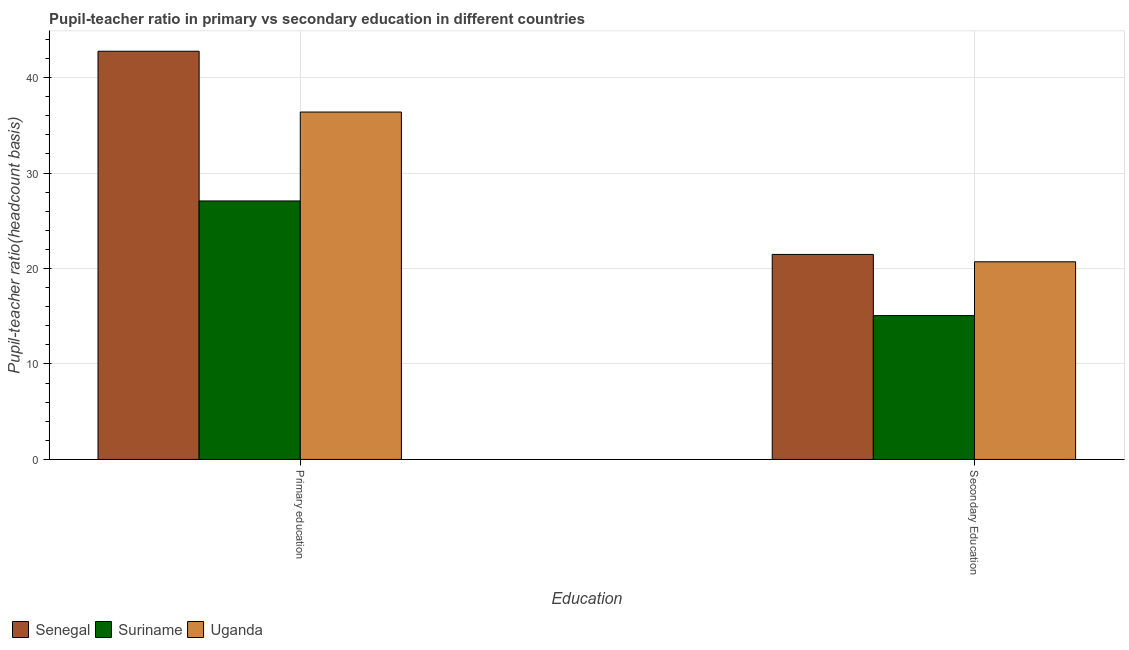Are the number of bars per tick equal to the number of legend labels?
Make the answer very short. Yes. How many bars are there on the 2nd tick from the left?
Keep it short and to the point. 3. How many bars are there on the 2nd tick from the right?
Provide a succinct answer. 3. What is the pupil-teacher ratio in primary education in Uganda?
Give a very brief answer. 36.39. Across all countries, what is the maximum pupil teacher ratio on secondary education?
Ensure brevity in your answer.  21.48. Across all countries, what is the minimum pupil teacher ratio on secondary education?
Your answer should be very brief. 15.07. In which country was the pupil teacher ratio on secondary education maximum?
Provide a short and direct response. Senegal. In which country was the pupil-teacher ratio in primary education minimum?
Provide a succinct answer. Suriname. What is the total pupil-teacher ratio in primary education in the graph?
Your answer should be compact. 106.23. What is the difference between the pupil-teacher ratio in primary education in Suriname and that in Senegal?
Offer a terse response. -15.68. What is the difference between the pupil-teacher ratio in primary education in Senegal and the pupil teacher ratio on secondary education in Suriname?
Make the answer very short. 27.7. What is the average pupil teacher ratio on secondary education per country?
Offer a very short reply. 19.08. What is the difference between the pupil teacher ratio on secondary education and pupil-teacher ratio in primary education in Uganda?
Provide a succinct answer. -15.69. In how many countries, is the pupil-teacher ratio in primary education greater than 32 ?
Provide a short and direct response. 2. What is the ratio of the pupil teacher ratio on secondary education in Suriname to that in Senegal?
Your answer should be very brief. 0.7. Is the pupil teacher ratio on secondary education in Uganda less than that in Senegal?
Ensure brevity in your answer.  Yes. What does the 3rd bar from the left in Primary education represents?
Give a very brief answer. Uganda. What does the 3rd bar from the right in Primary education represents?
Offer a terse response. Senegal. How many countries are there in the graph?
Offer a terse response. 3. Does the graph contain any zero values?
Offer a very short reply. No. Where does the legend appear in the graph?
Make the answer very short. Bottom left. How many legend labels are there?
Provide a short and direct response. 3. What is the title of the graph?
Your answer should be compact. Pupil-teacher ratio in primary vs secondary education in different countries. Does "Hungary" appear as one of the legend labels in the graph?
Offer a very short reply. No. What is the label or title of the X-axis?
Your response must be concise. Education. What is the label or title of the Y-axis?
Provide a short and direct response. Pupil-teacher ratio(headcount basis). What is the Pupil-teacher ratio(headcount basis) of Senegal in Primary education?
Your response must be concise. 42.76. What is the Pupil-teacher ratio(headcount basis) in Suriname in Primary education?
Offer a very short reply. 27.08. What is the Pupil-teacher ratio(headcount basis) of Uganda in Primary education?
Provide a short and direct response. 36.39. What is the Pupil-teacher ratio(headcount basis) in Senegal in Secondary Education?
Your answer should be very brief. 21.48. What is the Pupil-teacher ratio(headcount basis) of Suriname in Secondary Education?
Make the answer very short. 15.07. What is the Pupil-teacher ratio(headcount basis) in Uganda in Secondary Education?
Make the answer very short. 20.7. Across all Education, what is the maximum Pupil-teacher ratio(headcount basis) in Senegal?
Offer a terse response. 42.76. Across all Education, what is the maximum Pupil-teacher ratio(headcount basis) of Suriname?
Offer a terse response. 27.08. Across all Education, what is the maximum Pupil-teacher ratio(headcount basis) of Uganda?
Give a very brief answer. 36.39. Across all Education, what is the minimum Pupil-teacher ratio(headcount basis) in Senegal?
Give a very brief answer. 21.48. Across all Education, what is the minimum Pupil-teacher ratio(headcount basis) of Suriname?
Ensure brevity in your answer.  15.07. Across all Education, what is the minimum Pupil-teacher ratio(headcount basis) in Uganda?
Offer a terse response. 20.7. What is the total Pupil-teacher ratio(headcount basis) of Senegal in the graph?
Provide a short and direct response. 64.24. What is the total Pupil-teacher ratio(headcount basis) of Suriname in the graph?
Offer a terse response. 42.14. What is the total Pupil-teacher ratio(headcount basis) in Uganda in the graph?
Your answer should be compact. 57.1. What is the difference between the Pupil-teacher ratio(headcount basis) of Senegal in Primary education and that in Secondary Education?
Your response must be concise. 21.28. What is the difference between the Pupil-teacher ratio(headcount basis) in Suriname in Primary education and that in Secondary Education?
Your answer should be compact. 12.01. What is the difference between the Pupil-teacher ratio(headcount basis) in Uganda in Primary education and that in Secondary Education?
Offer a terse response. 15.69. What is the difference between the Pupil-teacher ratio(headcount basis) in Senegal in Primary education and the Pupil-teacher ratio(headcount basis) in Suriname in Secondary Education?
Provide a succinct answer. 27.7. What is the difference between the Pupil-teacher ratio(headcount basis) of Senegal in Primary education and the Pupil-teacher ratio(headcount basis) of Uganda in Secondary Education?
Offer a very short reply. 22.06. What is the difference between the Pupil-teacher ratio(headcount basis) in Suriname in Primary education and the Pupil-teacher ratio(headcount basis) in Uganda in Secondary Education?
Provide a succinct answer. 6.37. What is the average Pupil-teacher ratio(headcount basis) of Senegal per Education?
Your answer should be compact. 32.12. What is the average Pupil-teacher ratio(headcount basis) of Suriname per Education?
Provide a short and direct response. 21.07. What is the average Pupil-teacher ratio(headcount basis) in Uganda per Education?
Keep it short and to the point. 28.55. What is the difference between the Pupil-teacher ratio(headcount basis) of Senegal and Pupil-teacher ratio(headcount basis) of Suriname in Primary education?
Provide a short and direct response. 15.68. What is the difference between the Pupil-teacher ratio(headcount basis) of Senegal and Pupil-teacher ratio(headcount basis) of Uganda in Primary education?
Ensure brevity in your answer.  6.37. What is the difference between the Pupil-teacher ratio(headcount basis) in Suriname and Pupil-teacher ratio(headcount basis) in Uganda in Primary education?
Your response must be concise. -9.31. What is the difference between the Pupil-teacher ratio(headcount basis) of Senegal and Pupil-teacher ratio(headcount basis) of Suriname in Secondary Education?
Provide a succinct answer. 6.41. What is the difference between the Pupil-teacher ratio(headcount basis) in Senegal and Pupil-teacher ratio(headcount basis) in Uganda in Secondary Education?
Provide a succinct answer. 0.77. What is the difference between the Pupil-teacher ratio(headcount basis) of Suriname and Pupil-teacher ratio(headcount basis) of Uganda in Secondary Education?
Provide a short and direct response. -5.64. What is the ratio of the Pupil-teacher ratio(headcount basis) in Senegal in Primary education to that in Secondary Education?
Make the answer very short. 1.99. What is the ratio of the Pupil-teacher ratio(headcount basis) in Suriname in Primary education to that in Secondary Education?
Provide a succinct answer. 1.8. What is the ratio of the Pupil-teacher ratio(headcount basis) of Uganda in Primary education to that in Secondary Education?
Your answer should be very brief. 1.76. What is the difference between the highest and the second highest Pupil-teacher ratio(headcount basis) of Senegal?
Give a very brief answer. 21.28. What is the difference between the highest and the second highest Pupil-teacher ratio(headcount basis) of Suriname?
Make the answer very short. 12.01. What is the difference between the highest and the second highest Pupil-teacher ratio(headcount basis) in Uganda?
Keep it short and to the point. 15.69. What is the difference between the highest and the lowest Pupil-teacher ratio(headcount basis) of Senegal?
Offer a very short reply. 21.28. What is the difference between the highest and the lowest Pupil-teacher ratio(headcount basis) of Suriname?
Provide a short and direct response. 12.01. What is the difference between the highest and the lowest Pupil-teacher ratio(headcount basis) in Uganda?
Ensure brevity in your answer.  15.69. 